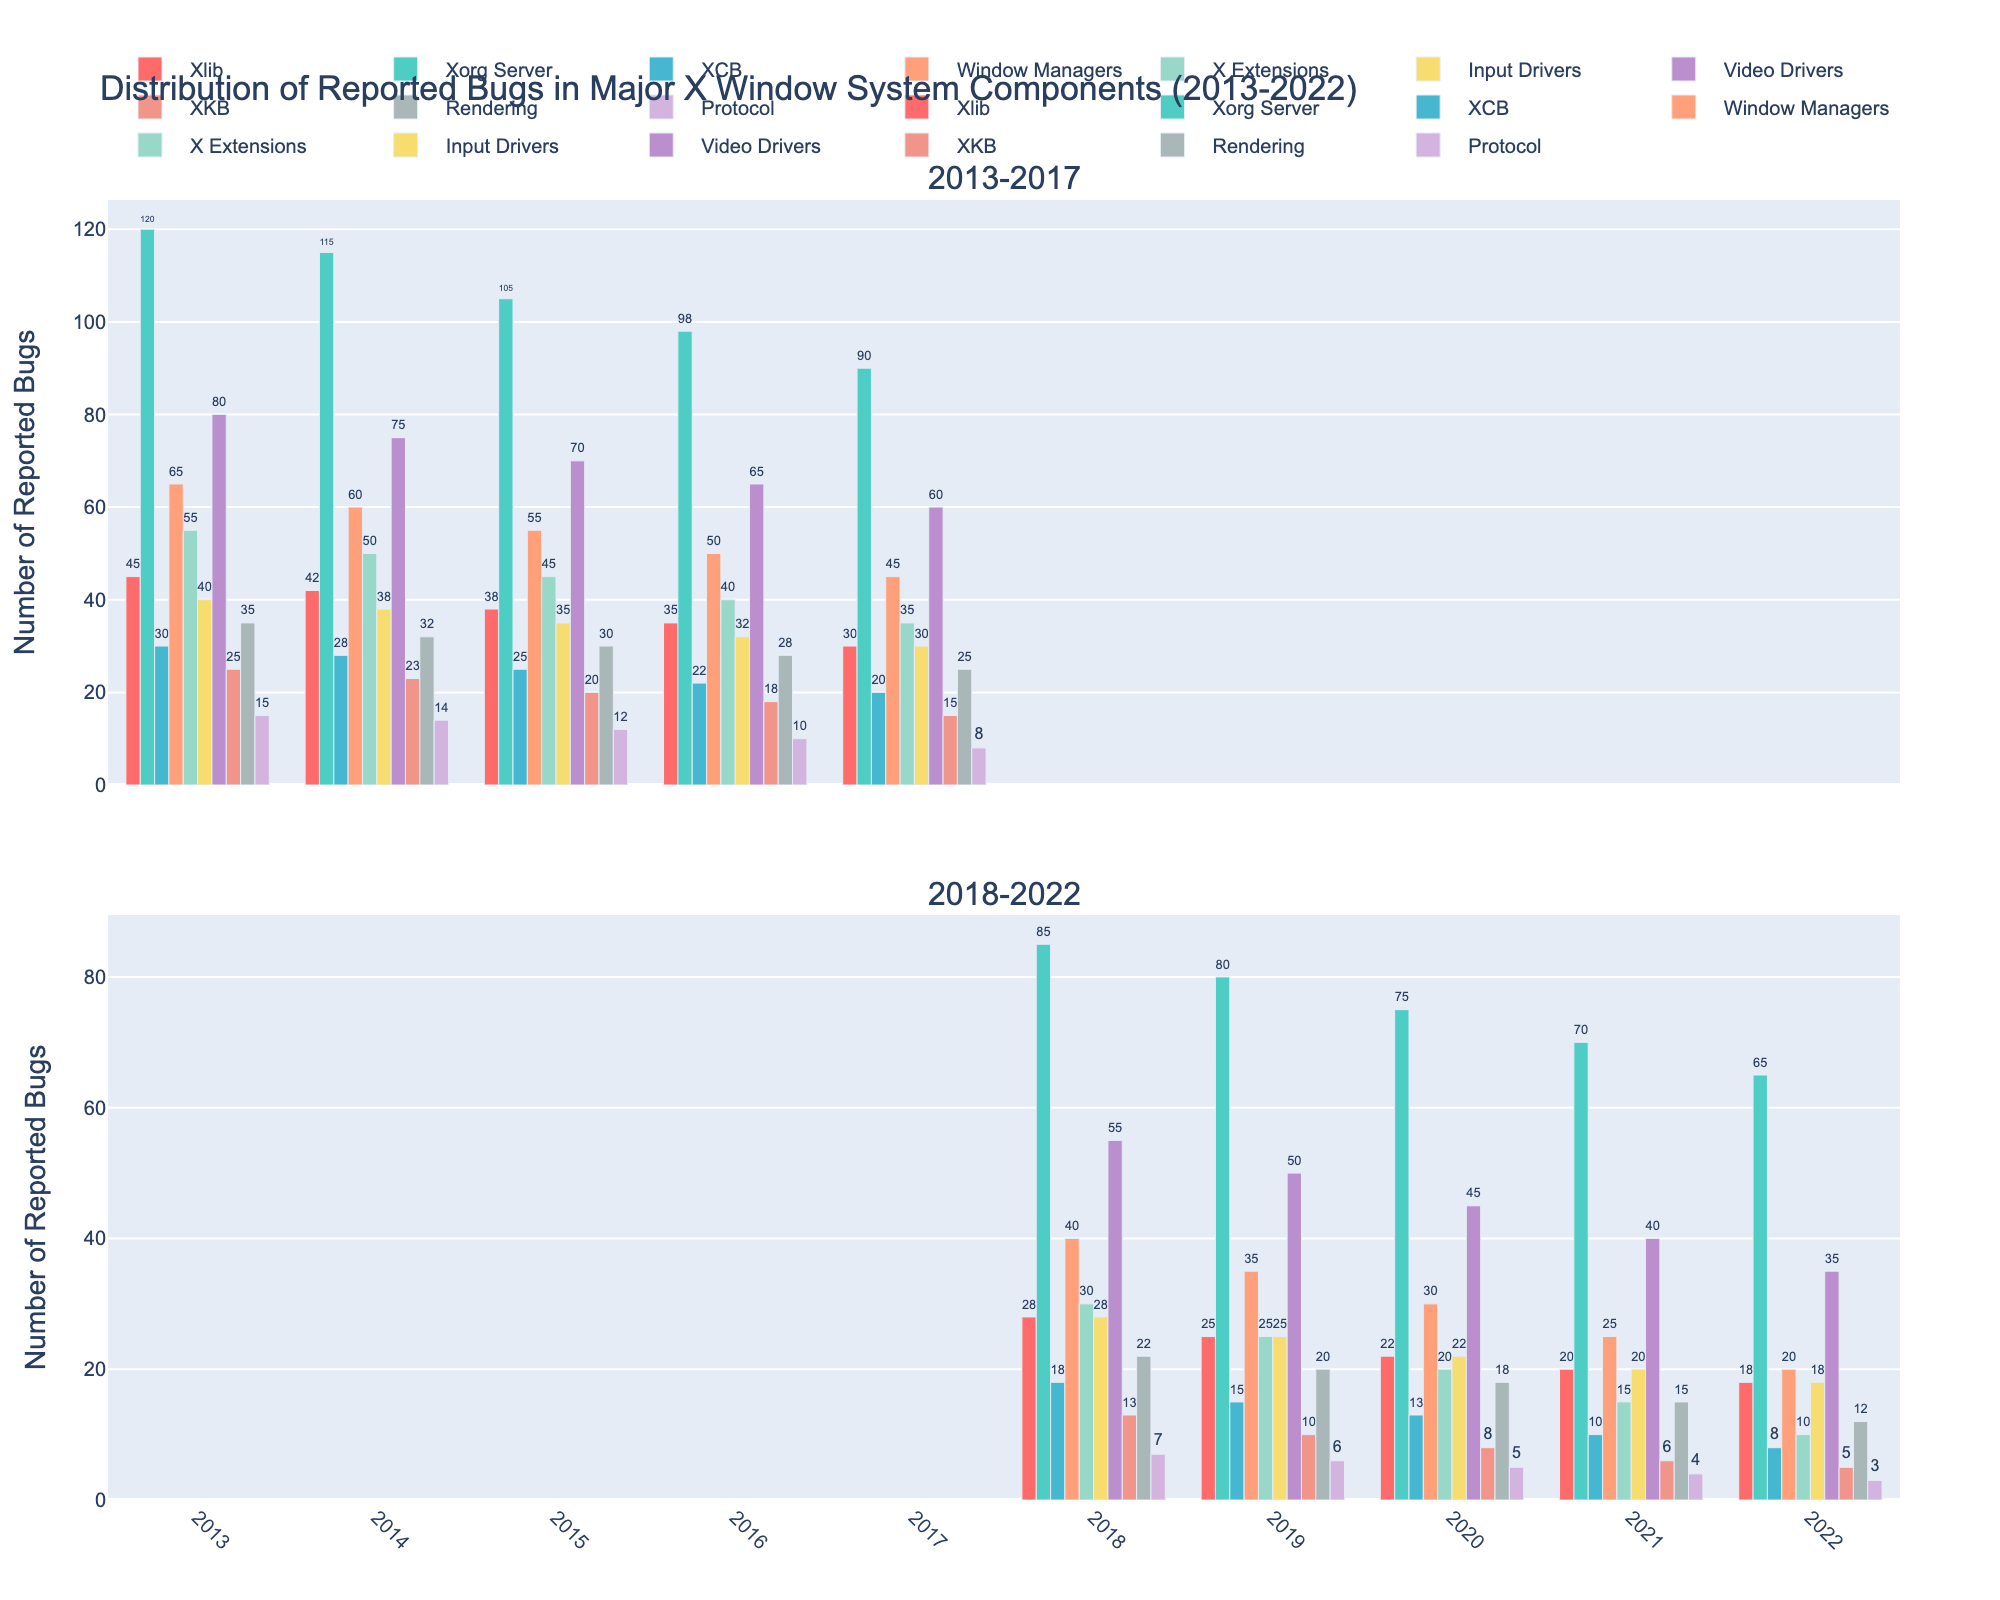Which X Window System component had the highest number of reported bugs in 2014? To find the component with the highest number of reported bugs in 2014, look at all the bars for that year and identify the tallest one.
Answer: Xorg Server How did the number of bugs reported for Xlib change from 2013 to 2022? Observe the height of the bars representing the number of bugs for Xlib across the years 2013 to 2022. The bars become shorter each year.
Answer: Decreased Which component saw the biggest reduction in reported bugs from 2013 to 2022? Compare the height of the bars in 2013 and 2022 for each component to see which had the largest decrease. Xorg Server had the largest decrease from 120 to 65.
Answer: Xorg Server Between 2013 and 2017, which component had the smallest number of reported bugs consistently every year? For the years 2013 to 2017, find the component whose bars are consistently the shortest each year. Protocol matches this description.
Answer: Protocol What is the total number of reported bugs for Video Drivers in 2018 and 2022 combined? To find the total number of reported bugs, add the value from 2018 (55) to the value from 2022 (35).
Answer: 90 Which two components had the same number of reported bugs in 2022? Look for bars with the same height in 2022. Xlib and Input Drivers both had 18 reported bugs.
Answer: Xlib and Input Drivers How did the number of reported bugs for Rendering change from 2016 to 2017 compared to the change from 2017 to 2018? Compare the heights of the bars for Rendering in 2016, 2017, and 2018. From 2016 to 2017, it decreased from 28 to 25. From 2017 to 2018, it decreased again from 25 to 22.
Answer: Decreased both times Which year saw the most dramatic improvement (decrease) in the number of bugs reported for Xorg Server? Examine the year-to-year changes in the height of the bars for Xorg Server. The decrease from 2014 to 2015 (115 to 105) appears larger than other single-year changes.
Answer: 2014 to 2015 What is the average number of reported bugs for XKB over the last decade? To calculate the average, sum the number of reported bugs for XKB from 2013 to 2022 (25+23+20+18+15+13+10+8+6+5=143) and divide by the number of years (10).
Answer: 14.3 How many more bugs were reported for Window Managers than for Protocol in 2015? Subtract the number of bugs reported for Protocol in 2015 (12) from those for Window Managers (55) to get the difference.
Answer: 43 